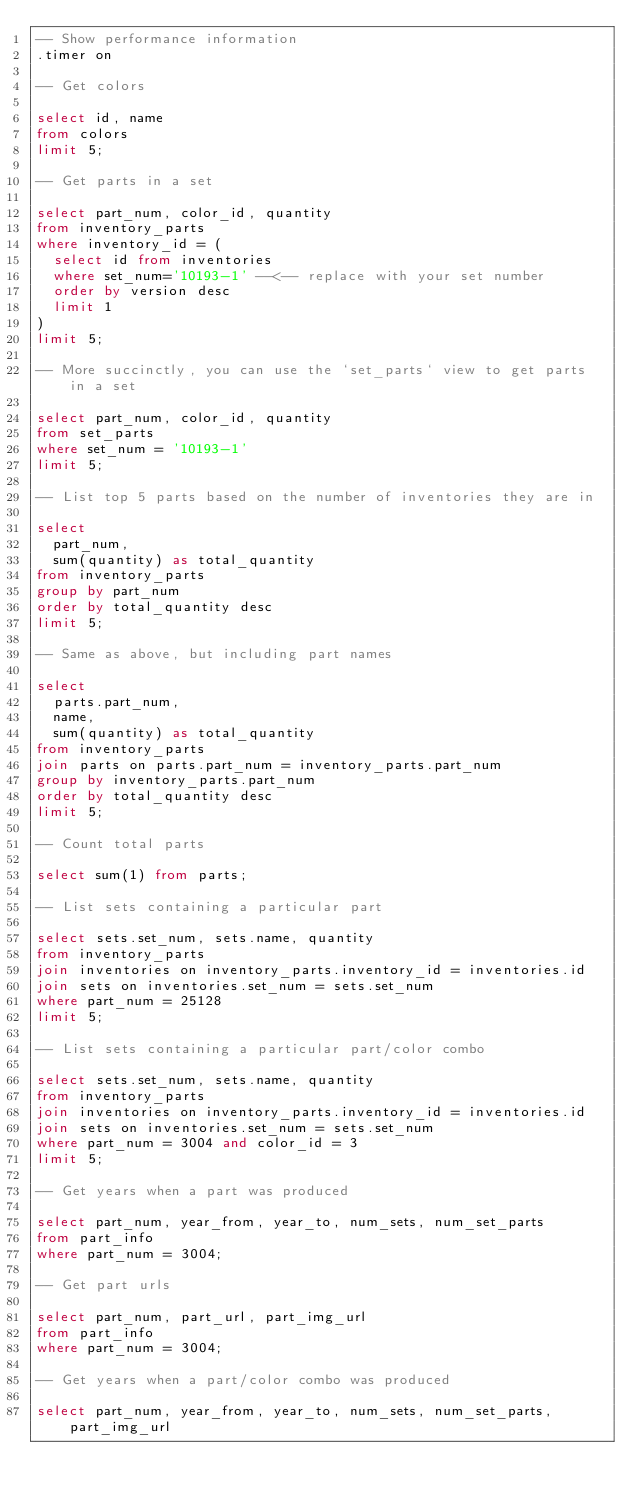<code> <loc_0><loc_0><loc_500><loc_500><_SQL_>-- Show performance information
.timer on

-- Get colors

select id, name 
from colors
limit 5;

-- Get parts in a set

select part_num, color_id, quantity
from inventory_parts 
where inventory_id = (
  select id from inventories 
  where set_num='10193-1' --<-- replace with your set number
  order by version desc
  limit 1
)
limit 5;

-- More succinctly, you can use the `set_parts` view to get parts in a set

select part_num, color_id, quantity
from set_parts
where set_num = '10193-1'
limit 5;

-- List top 5 parts based on the number of inventories they are in

select 
  part_num,
  sum(quantity) as total_quantity 
from inventory_parts
group by part_num
order by total_quantity desc
limit 5;

-- Same as above, but including part names

select 
  parts.part_num, 
  name, 
  sum(quantity) as total_quantity 
from inventory_parts
join parts on parts.part_num = inventory_parts.part_num
group by inventory_parts.part_num
order by total_quantity desc
limit 5;

-- Count total parts

select sum(1) from parts;

-- List sets containing a particular part

select sets.set_num, sets.name, quantity
from inventory_parts
join inventories on inventory_parts.inventory_id = inventories.id
join sets on inventories.set_num = sets.set_num
where part_num = 25128
limit 5;

-- List sets containing a particular part/color combo

select sets.set_num, sets.name, quantity
from inventory_parts
join inventories on inventory_parts.inventory_id = inventories.id
join sets on inventories.set_num = sets.set_num
where part_num = 3004 and color_id = 3
limit 5;

-- Get years when a part was produced

select part_num, year_from, year_to, num_sets, num_set_parts
from part_info
where part_num = 3004;

-- Get part urls

select part_num, part_url, part_img_url
from part_info
where part_num = 3004;

-- Get years when a part/color combo was produced

select part_num, year_from, year_to, num_sets, num_set_parts, part_img_url</code> 